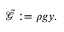<formula> <loc_0><loc_0><loc_500><loc_500>\begin{array} { r } { \bar { \ m a t h s c r { G } } \colon = \rho g y . } \end{array}</formula> 